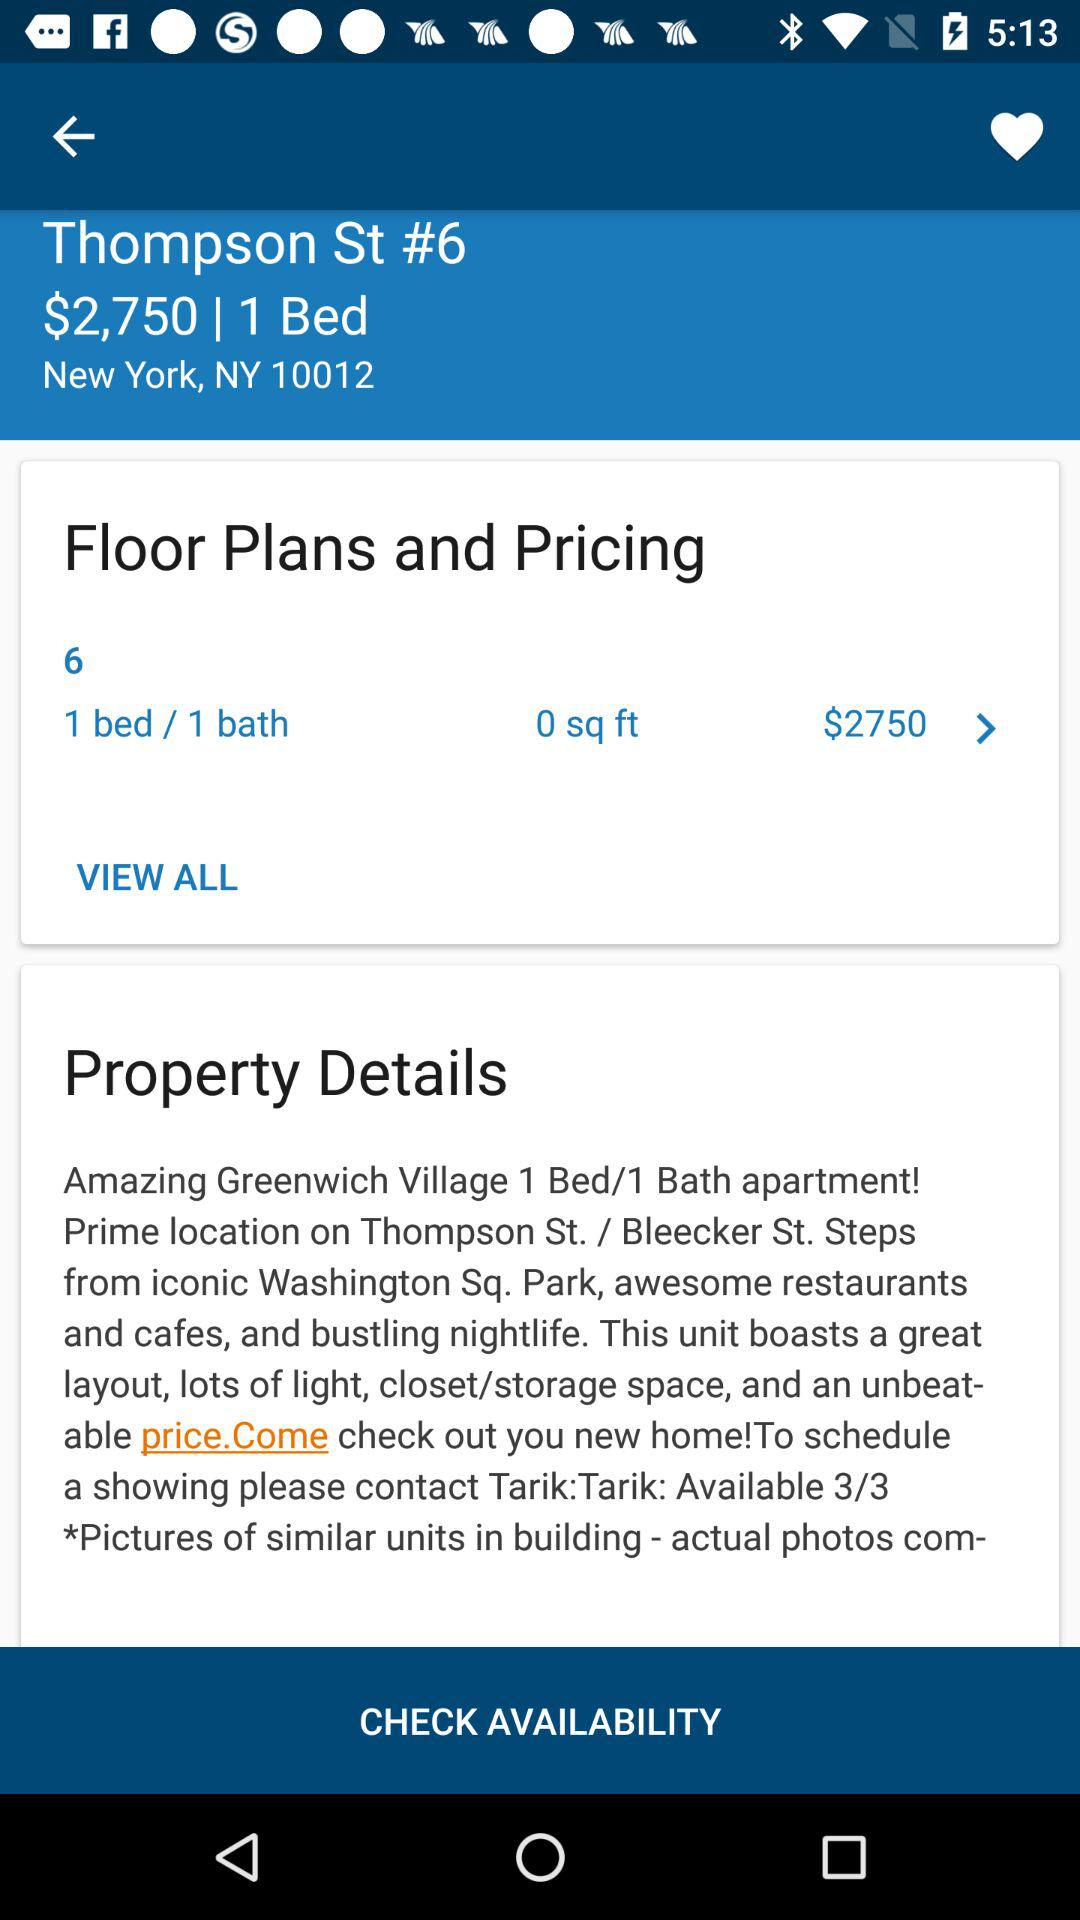What is the price of the apartment with one bed? The price is $2750. 